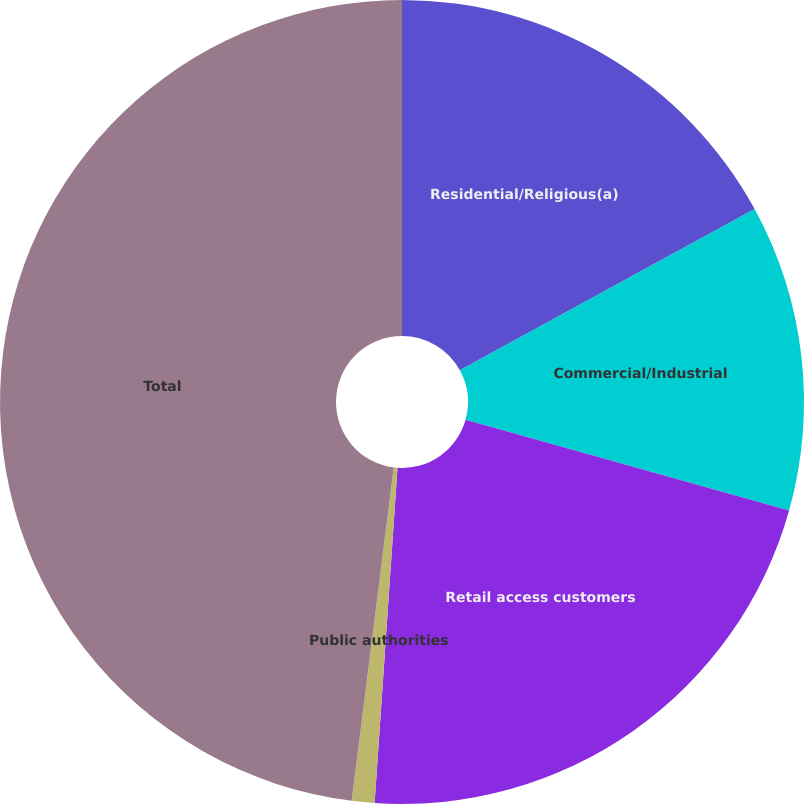Convert chart. <chart><loc_0><loc_0><loc_500><loc_500><pie_chart><fcel>Residential/Religious(a)<fcel>Commercial/Industrial<fcel>Retail access customers<fcel>Public authorities<fcel>Total<nl><fcel>17.03%<fcel>12.32%<fcel>21.74%<fcel>0.91%<fcel>48.01%<nl></chart> 